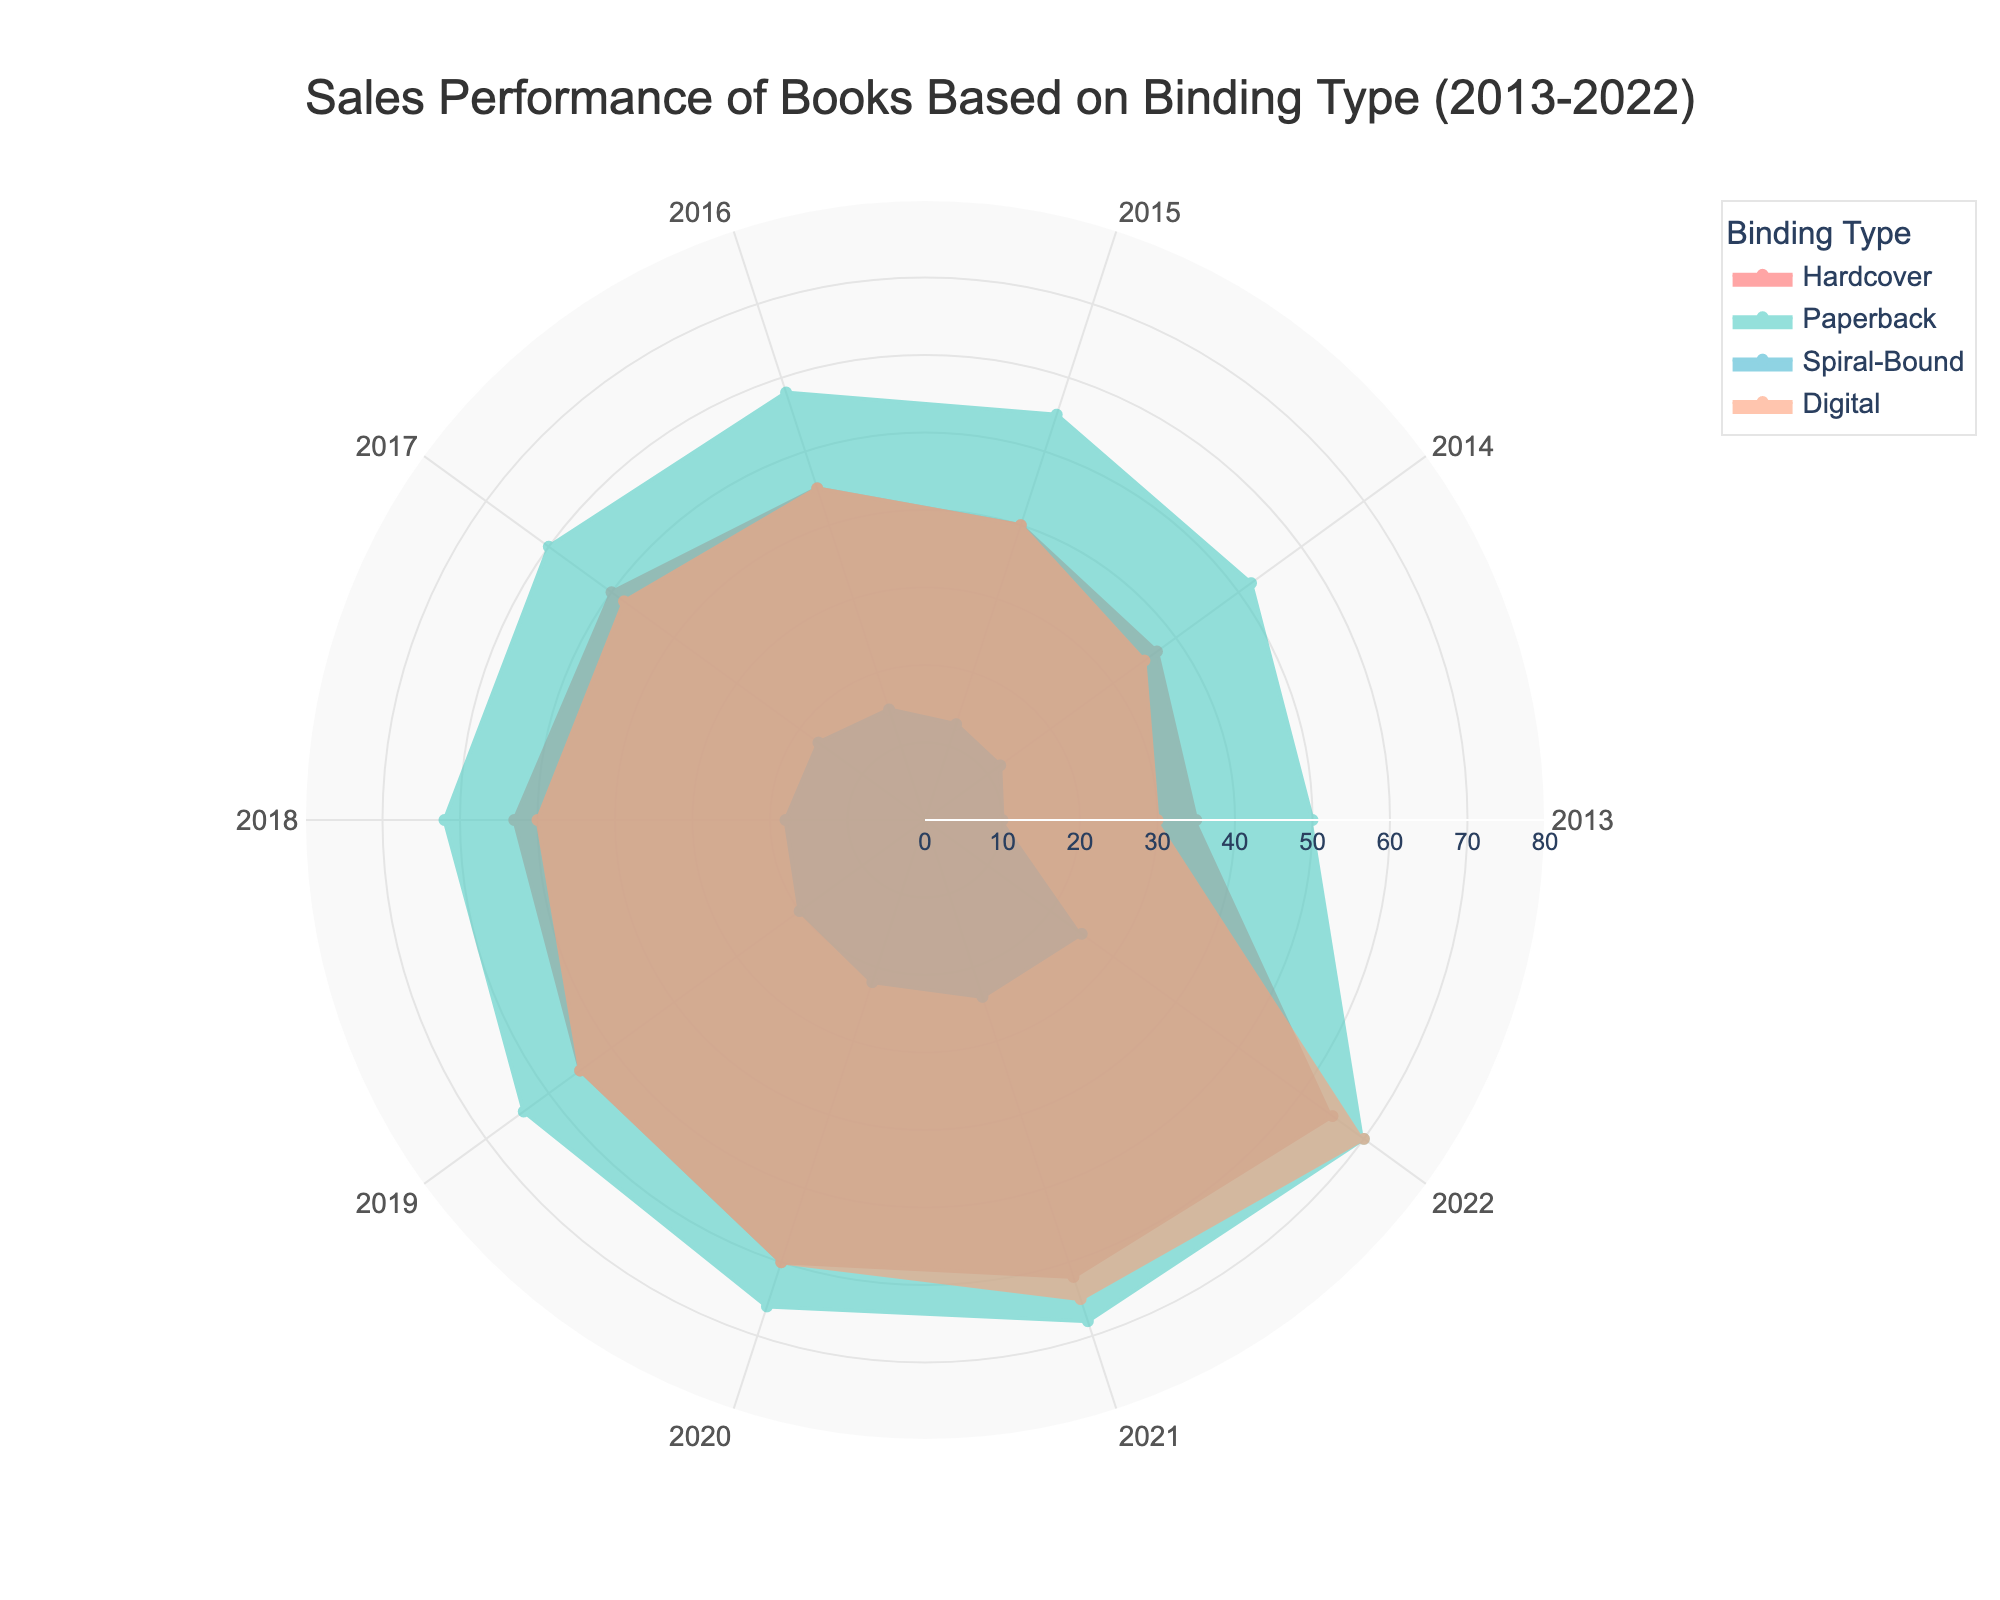How has the sales performance of Digital binding types changed from 2013 to 2022? Look at the value of Digital binding type across the years from 2013 to 2022 and observe the increasing trend.
Answer: Increased steadily What is the difference in sales between Hardcover and Spiral-Bound books in 2018? Find the sales value for both Hardcover and Spiral-Bound books in 2018 (Hardcover: 53, Spiral-Bound: 18) and subtract Spiral-Bound from Hardcover (53 - 18 = 35).
Answer: 35 Which binding type has the highest sales in 2022? Identify the highest value in 2022: Hardcover (65), Paperback (70), Spiral-Bound (25), Digital (70). The highest values are Paperback and Digital, both at 70.
Answer: Paperback and Digital Between which years did Digital binding see the most significant increase in sales? Compare the differences in sales of Digital binding between successive years and identify the largest increase: 2013-2014 (5), 2014-2015 (5), 2015-2016 (5), 2016-2017 (3), 2017-2018 (2), 2018-2019 (5), 2019-2020 (5), 2020-2021 (5), 2021-2022 (5). The largest single increase is between 2013-2014, 2015-2016, 2018-2019, 2019-2020, and 2020-2021, each with an increase of 5 units.
Answer: 2013-2014, 2015-2016, 2018-2019, 2019-2020, 2020-2021 Which binding type had the lowest sales every year from 2013 to 2022? Identify the lowest value for each year: 2013 (Spiral-Bound: 10), 2014 (Spiral-Bound: 12), 2015 (Spiral-Bound: 13), 2016 (Spiral-Bound: 15), 2017 (Spiral-Bound: 17), 2018 (Spiral-Bound: 18), 2019 (Spiral-Bound: 20), 2020 (Spiral-Bound: 22), 2021 (Spiral-Bound: 24), 2022 (Spiral-Bound: 25). Spiral-Bound consistently has the lowest sales.
Answer: Spiral-Bound What is the average sales of Hardcover books over the last decade? Sum the sales values from 2013 to 2022 for Hardcover (35 + 37 + 40 + 45 + 50 + 53 + 55 + 60 + 62 + 65 = 502) and divide by 10 years (502 / 10). The average is 50.2.
Answer: 50.2 Did Paperback sales ever surpass Digital sales in any year? Compare the sales values of Paperback and Digital for each year: 2013 (Paperback: 50, Digital: 30), 2014 (Paperback: 52, Digital: 35), 2015 (Paperback: 55, Digital: 40), 2016 (Paperback: 58, Digital: 45), 2017 (Paperback: 60, Digital: 48), 2018 (Paperback: 62, Digital: 50), 2019 (Paperback: 64, Digital: 55), 2020 (Paperback: 66, Digital: 60), 2021 (Paperback: 68, Digital: 65), 2022 (Paperback: 70, Digital: 70). Paperback sales are higher until 2021.
Answer: Yes Which binding type shows the most consistent growth over the decade? Observe the trends for each binding type: Hardcover, Paperback, Spiral-Bound, and Digital across the years. Paperback and Digital show steady growth without any dips.
Answer: Paperback and Digital What was the combined sales of all binding types in 2020? Sum the sales values for all binding types in 2020: Hardcover (60), Paperback (66), Spiral-Bound (22), Digital (60). The combined sales is (60 + 66 + 22 + 60 = 208).
Answer: 208 